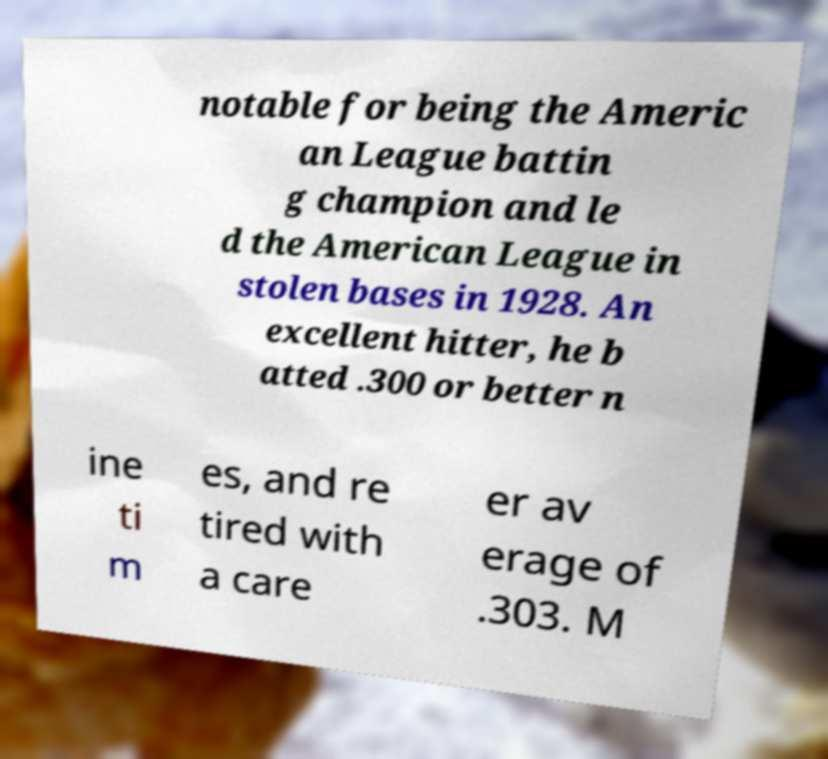What messages or text are displayed in this image? I need them in a readable, typed format. notable for being the Americ an League battin g champion and le d the American League in stolen bases in 1928. An excellent hitter, he b atted .300 or better n ine ti m es, and re tired with a care er av erage of .303. M 